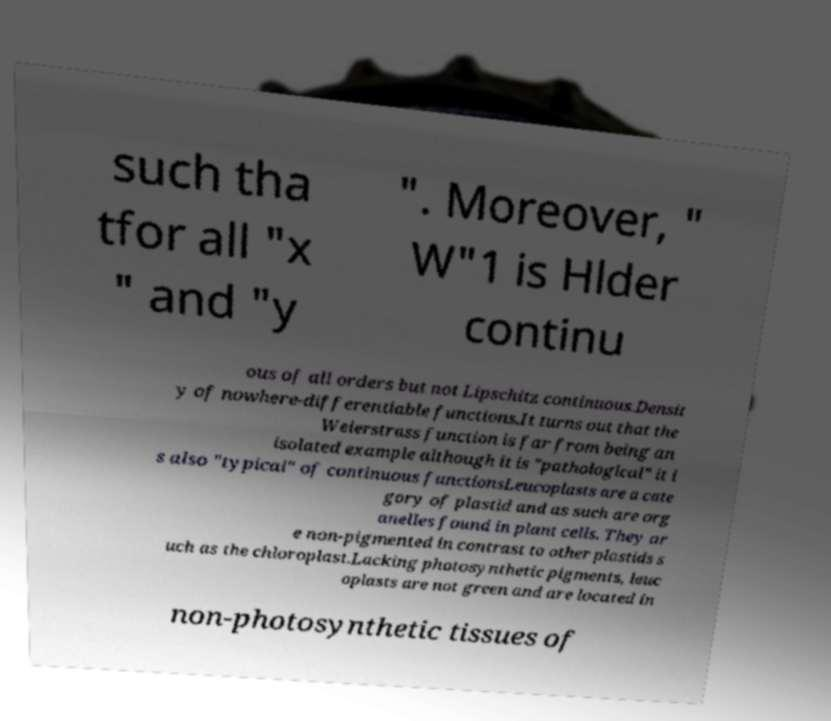What messages or text are displayed in this image? I need them in a readable, typed format. such tha tfor all "x " and "y ". Moreover, " W"1 is Hlder continu ous of all orders but not Lipschitz continuous.Densit y of nowhere-differentiable functions.It turns out that the Weierstrass function is far from being an isolated example although it is "pathological" it i s also "typical" of continuous functionsLeucoplasts are a cate gory of plastid and as such are org anelles found in plant cells. They ar e non-pigmented in contrast to other plastids s uch as the chloroplast.Lacking photosynthetic pigments, leuc oplasts are not green and are located in non-photosynthetic tissues of 